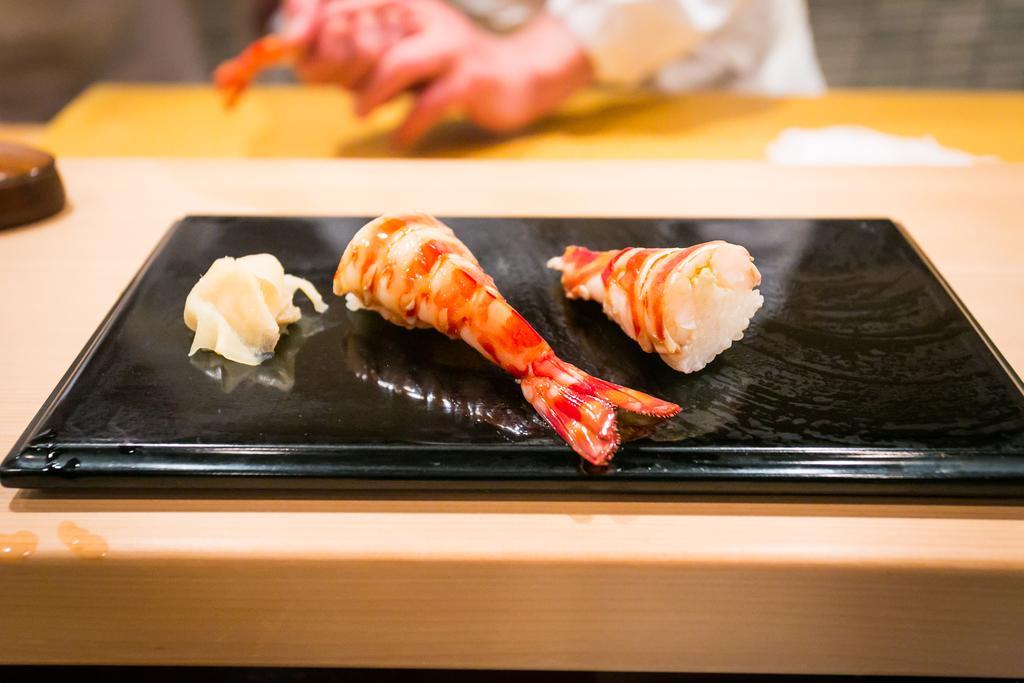Can you describe this image briefly? In this image I can see meat on an object and the background is blurry. 